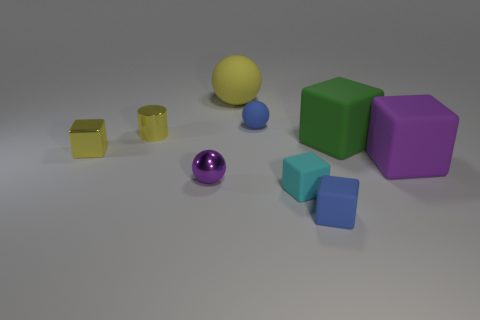What color is the tiny cylinder that is the same material as the small purple object? The tiny cylinder that shares the same smooth and shiny material as the small purple sphere is a vibrant yellow. 